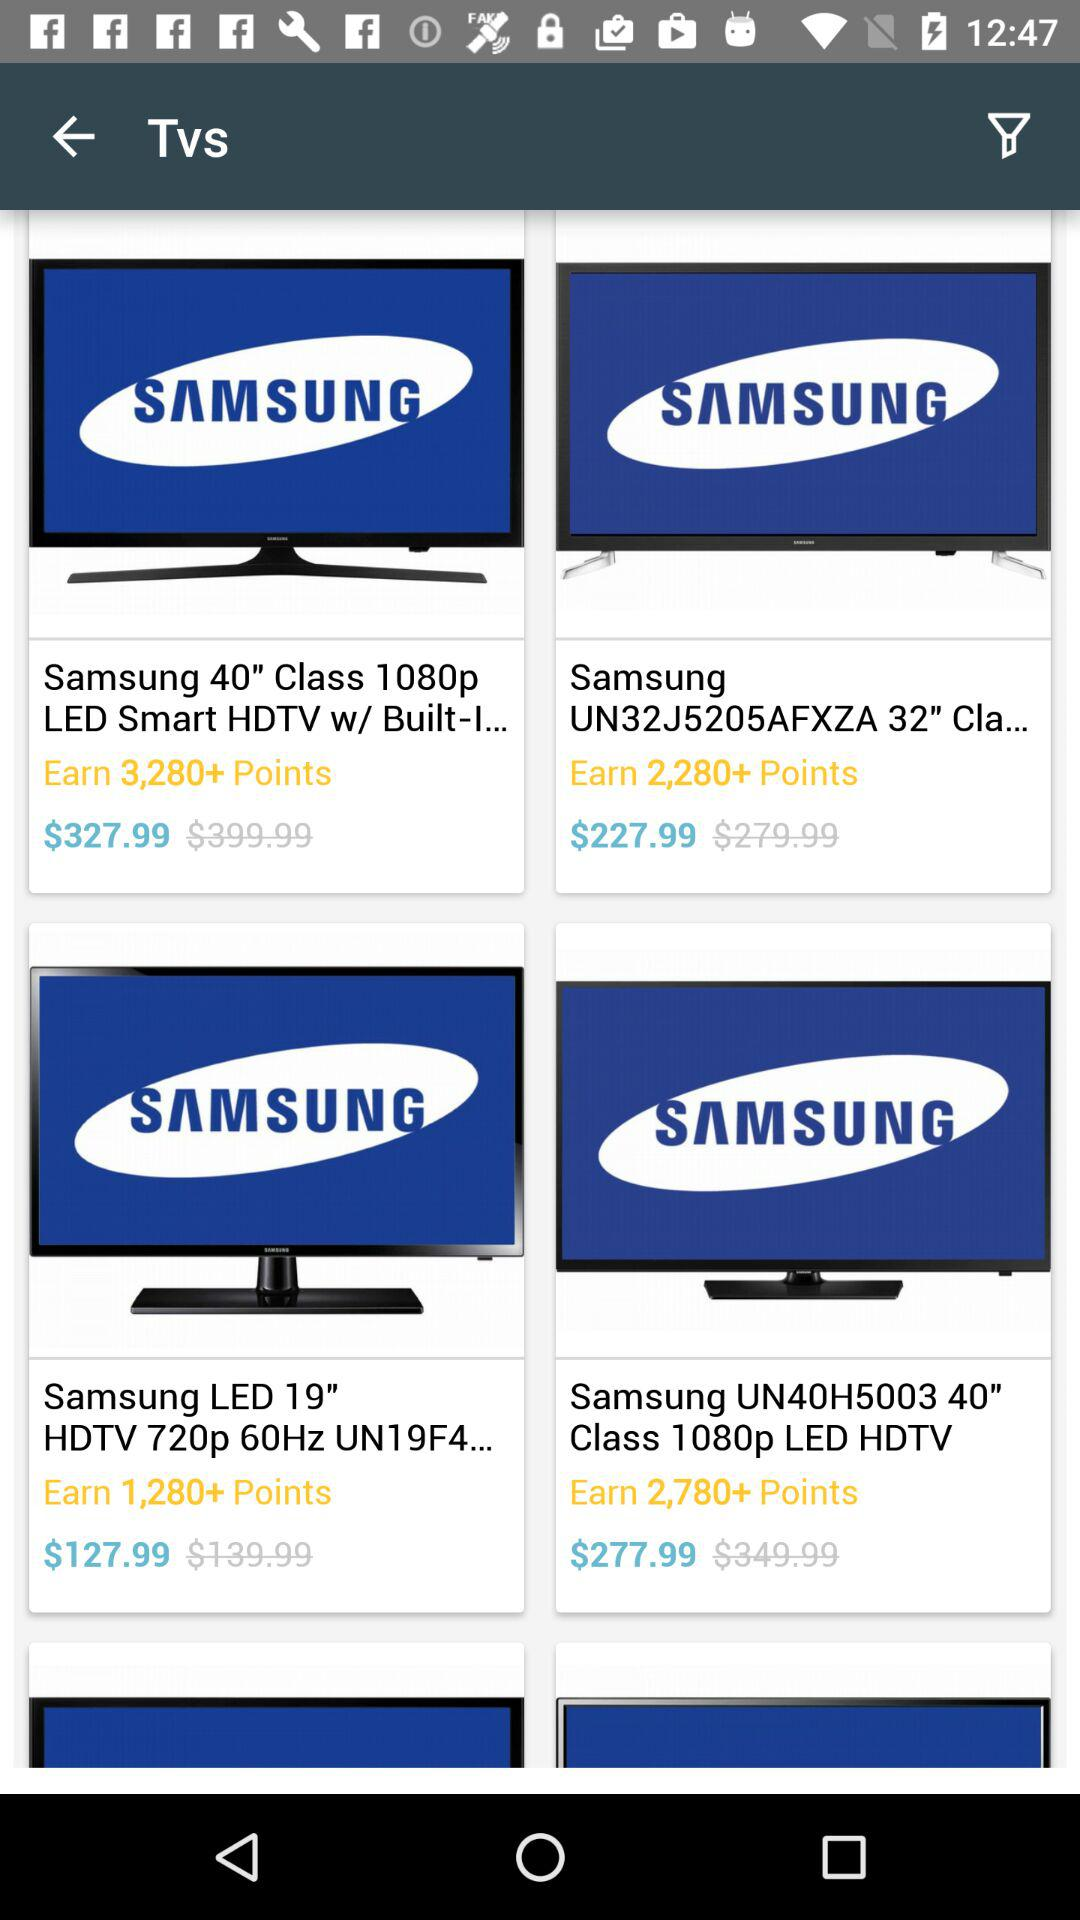What is the price of the "Samsung 40" Class 1080p LED Smart HDTV"? The price is $327.99. 